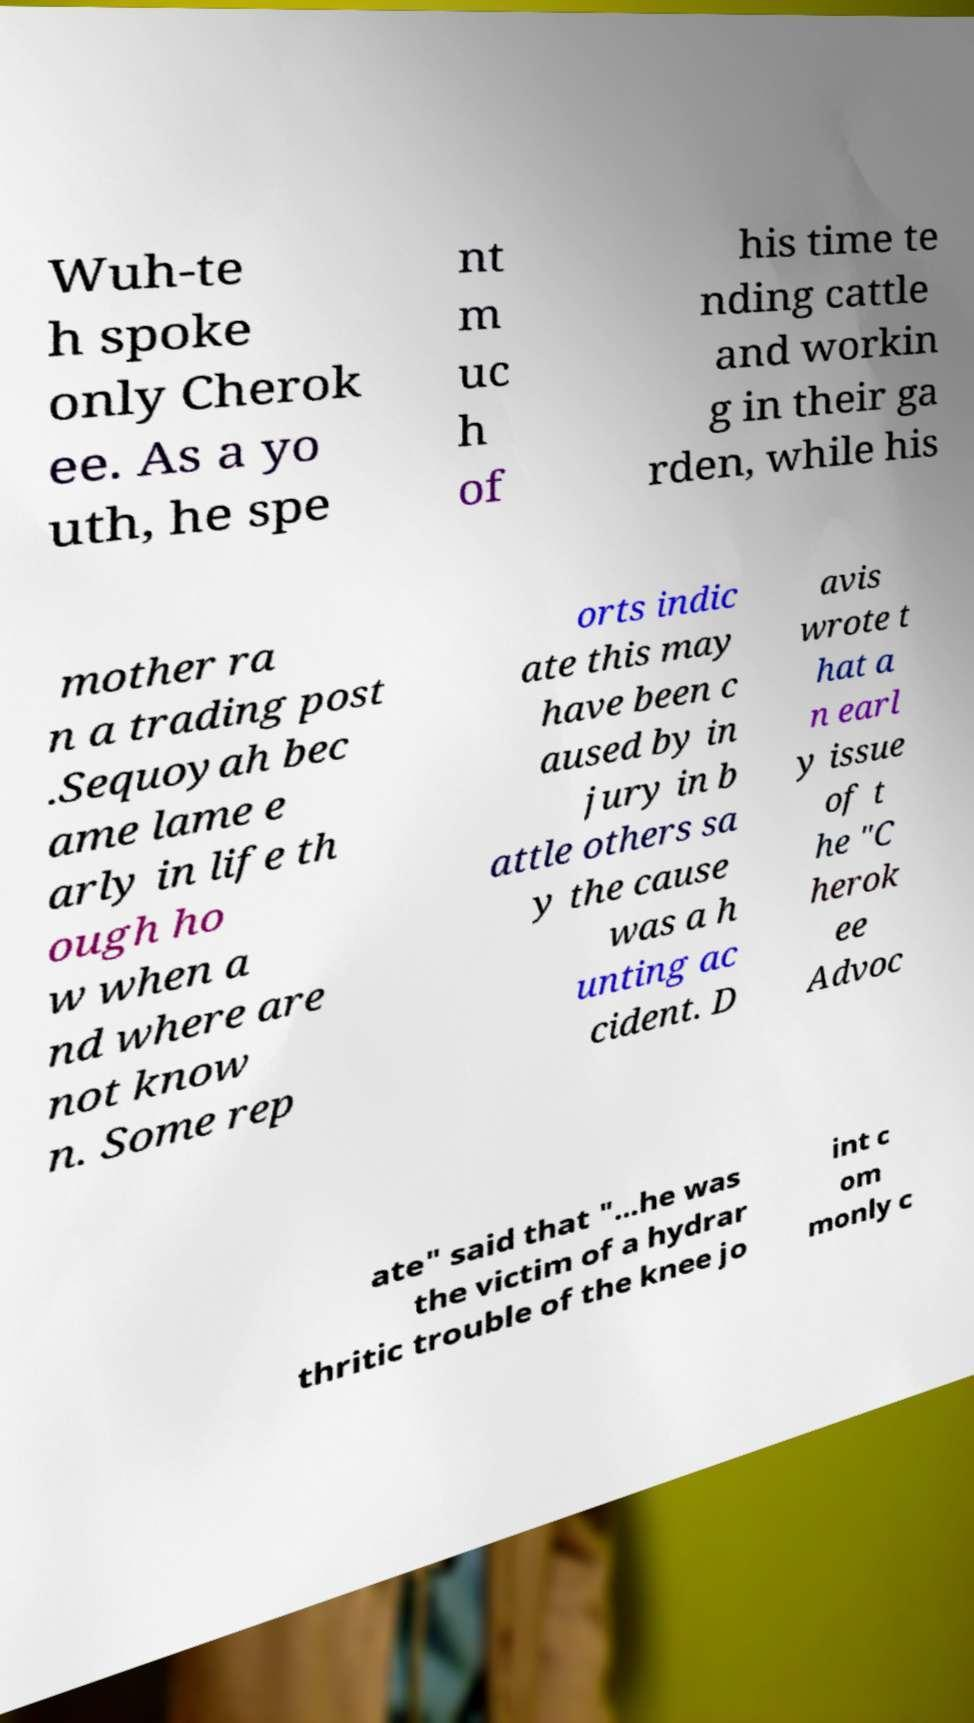Could you extract and type out the text from this image? Wuh-te h spoke only Cherok ee. As a yo uth, he spe nt m uc h of his time te nding cattle and workin g in their ga rden, while his mother ra n a trading post .Sequoyah bec ame lame e arly in life th ough ho w when a nd where are not know n. Some rep orts indic ate this may have been c aused by in jury in b attle others sa y the cause was a h unting ac cident. D avis wrote t hat a n earl y issue of t he "C herok ee Advoc ate" said that "...he was the victim of a hydrar thritic trouble of the knee jo int c om monly c 